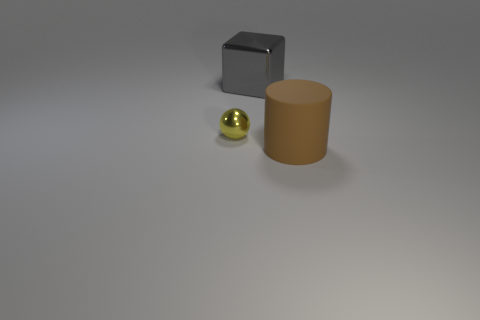Add 3 tiny balls. How many objects exist? 6 Subtract all cubes. How many objects are left? 2 Subtract 0 purple spheres. How many objects are left? 3 Subtract all large gray metal balls. Subtract all large objects. How many objects are left? 1 Add 2 metal things. How many metal things are left? 4 Add 1 tiny purple blocks. How many tiny purple blocks exist? 1 